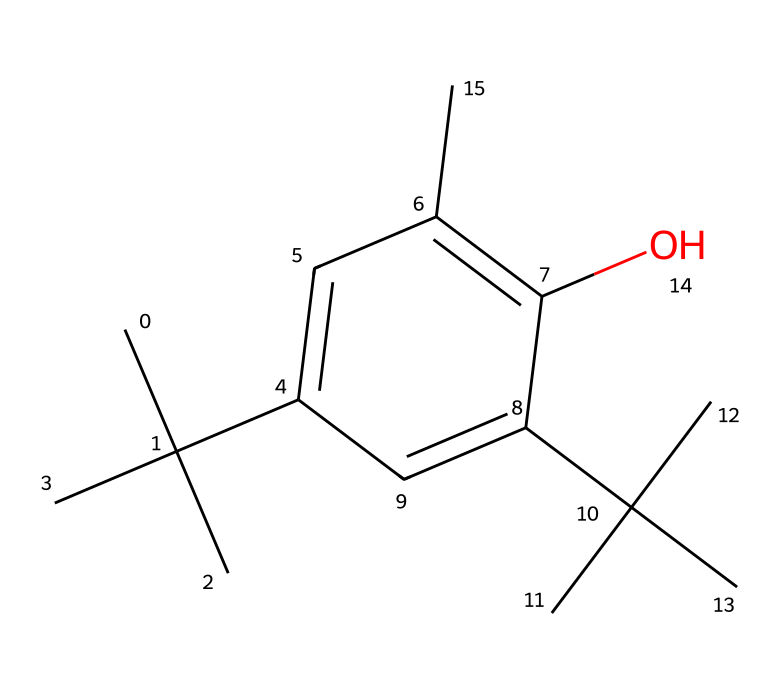What is the chemical name of the compound represented by the SMILES? The SMILES notation represents a chemical structure that corresponds to butylated hydroxytoluene (BHT), a well-known antioxidant.
Answer: butylated hydroxytoluene How many carbon atoms are present in this compound? By analyzing the SMILES representation, we can count a total of 15 carbon atoms, based on the branching and ring structure indicated in the notation.
Answer: 15 What functional group is present in the structure of BHT? The presence of the hydroxyl group (–OH) can be identified from the "O" in the SMILES notation, indicating a phenolic hydroxyl which is characteristic in antioxidants.
Answer: hydroxyl Does BHT contain any double bonds? Upon examining the SMILES structure, one can see that there are double bonds between carbon atoms in the aromatic ring indicative of unsaturation within the compound.
Answer: yes What is the main role of BHT as an antioxidant? BHT acts by preventing the oxidation of lipids and other cellular structures, protecting food quality and stability from rancidity and spoilage.
Answer: prevent oxidation Which part of the BHT structure is associated with its antioxidant activity? The hydroxyl group is key in BHT's structure; it contributes to the donation of hydrogen atoms, leading to the stabilization of free radicals.
Answer: hydroxyl group 